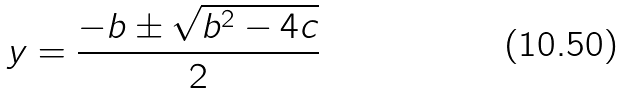<formula> <loc_0><loc_0><loc_500><loc_500>y = \frac { - b \pm \sqrt { b ^ { 2 } - 4 c } } { 2 }</formula> 